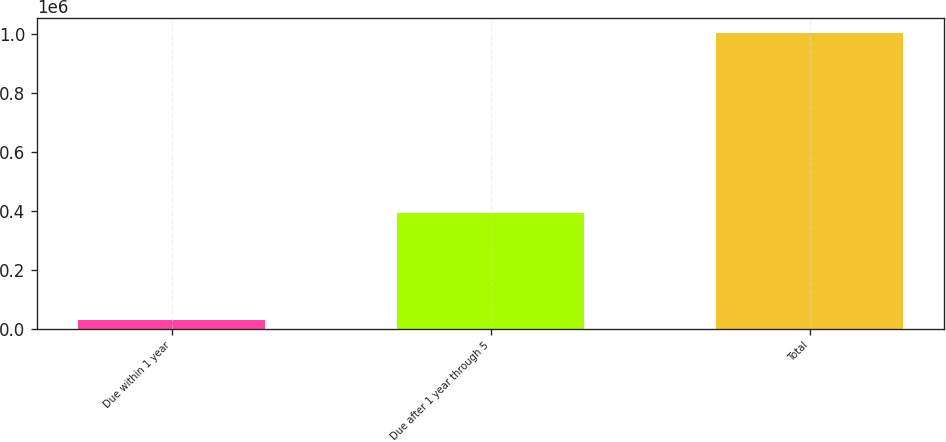<chart> <loc_0><loc_0><loc_500><loc_500><bar_chart><fcel>Due within 1 year<fcel>Due after 1 year through 5<fcel>Total<nl><fcel>27905<fcel>393114<fcel>1.00433e+06<nl></chart> 